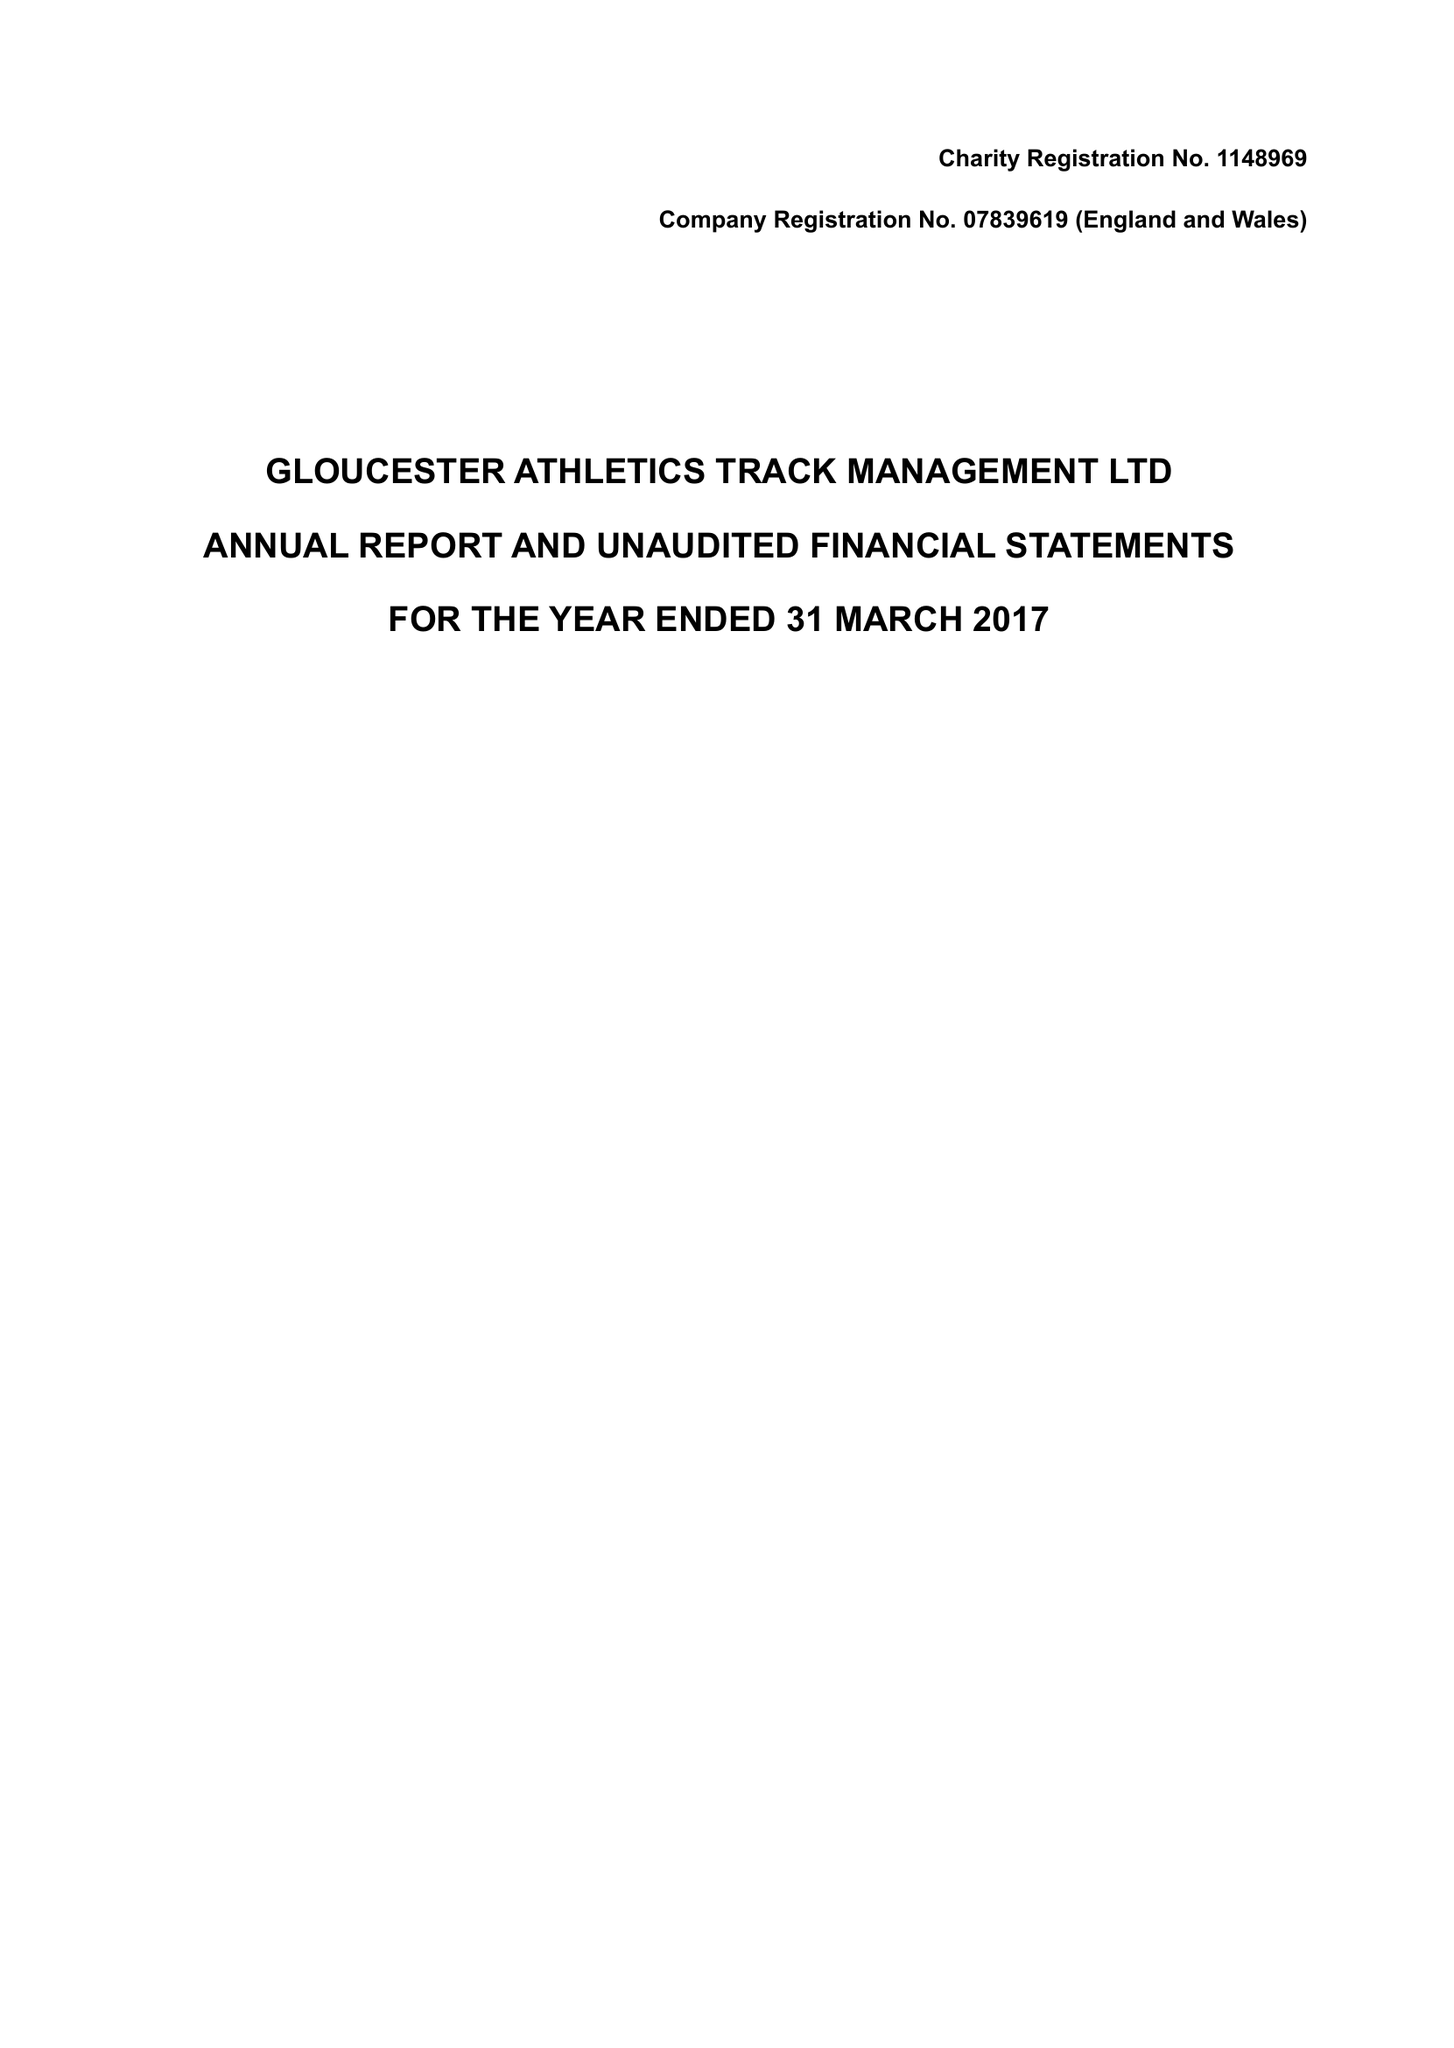What is the value for the address__street_line?
Answer the question using a single word or phrase. 13 ARDMORE CLOSE 